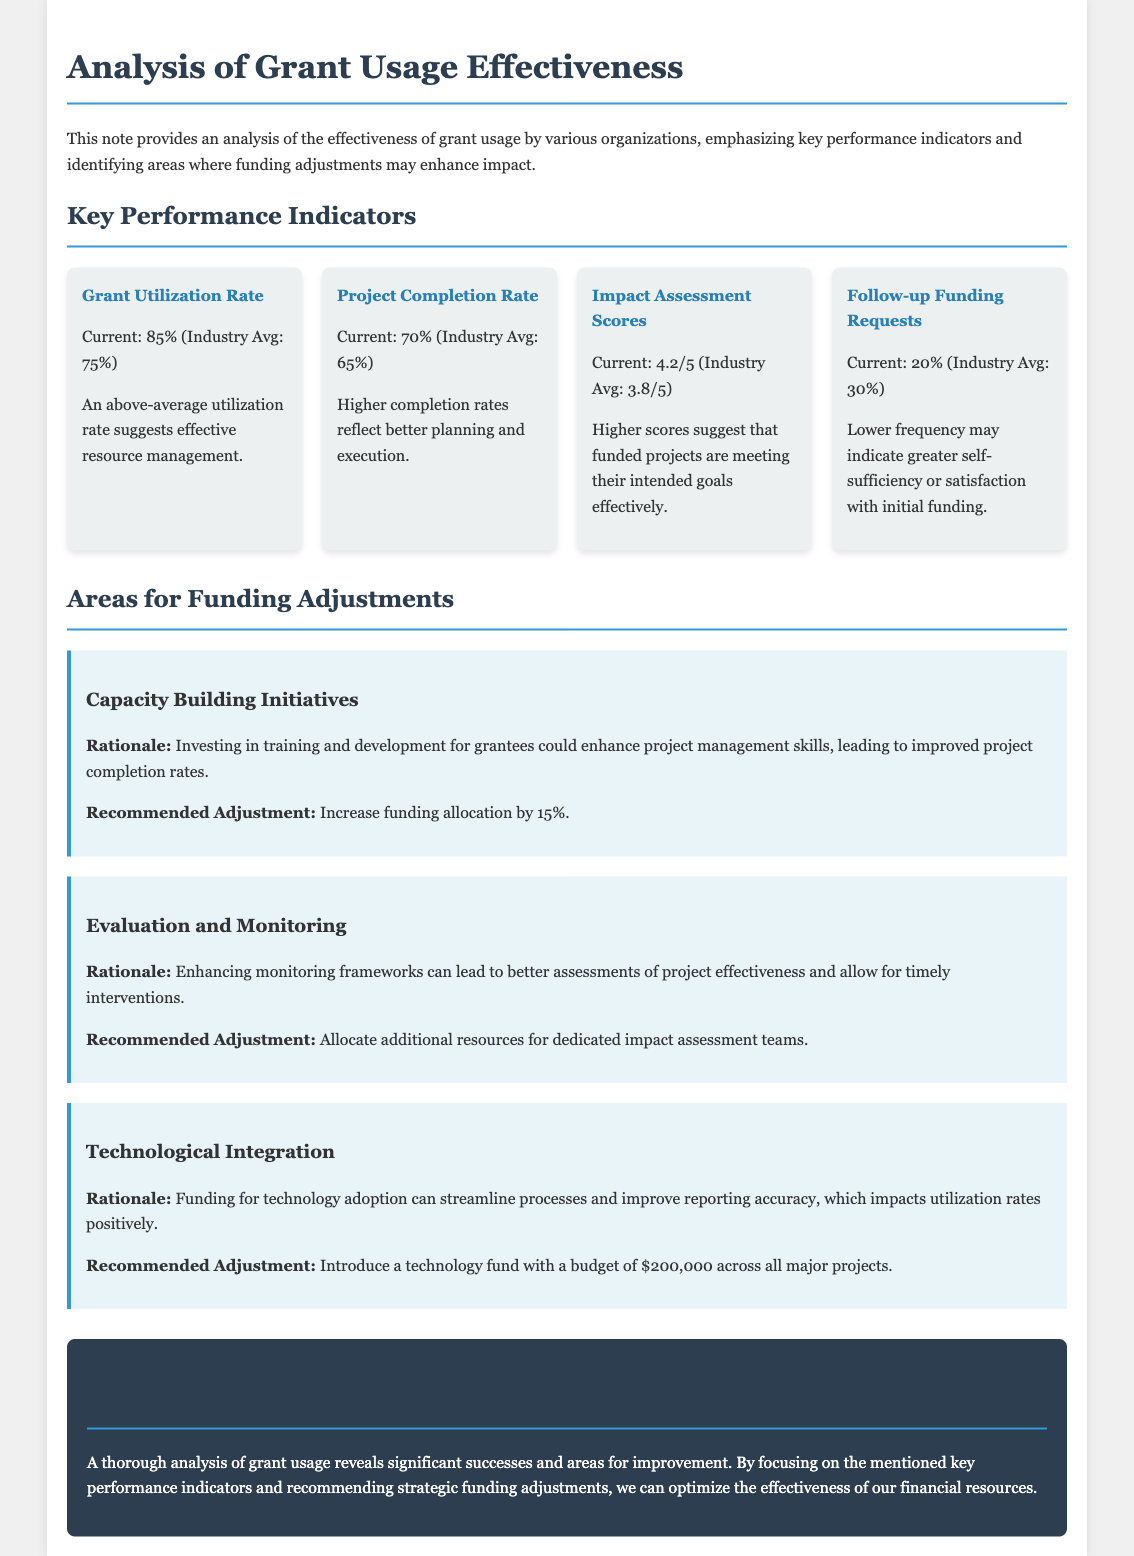What is the current Grant Utilization Rate? The current Grant Utilization Rate is given as 85%, which is noted in the KPIs section.
Answer: 85% What is the Project Completion Rate industry average? The industry average for the Project Completion Rate is stated as 65% in the document.
Answer: 65% What percentage of Follow-up Funding Requests is reported? The percentage of Follow-up Funding Requests indicated is 20%, mentioned within the KPIs.
Answer: 20% What is the recommended funding adjustment for Capacity Building Initiatives? The recommended funding adjustment for Capacity Building Initiatives is specified as an increase of 15%.
Answer: 15% What impact assessment score did the organization receive? The organization received an Impact Assessment Score of 4.2 out of 5, as detailed in the KPIs section.
Answer: 4.2/5 Why might increasing funding for Capacity Building Initiatives be beneficial? The rationale states that investing in training could enhance project management skills, impacting project completion rates positively.
Answer: Enhance project management skills What is suggested to improve Evaluation and Monitoring? The document recommends allocating additional resources for dedicated impact assessment teams to improve Evaluation and Monitoring.
Answer: Additional resources for assessment teams How much budget is suggested for technological integration? The budget suggested for technological integration across all major projects is $200,000, as mentioned in the funding adjustments area.
Answer: $200,000 What conclusion can be drawn from the analysis of grant usage? The conclusion drawn is that a thorough analysis reveals significant successes and areas for improvement in grant usage effectiveness.
Answer: Significant successes and areas for improvement 